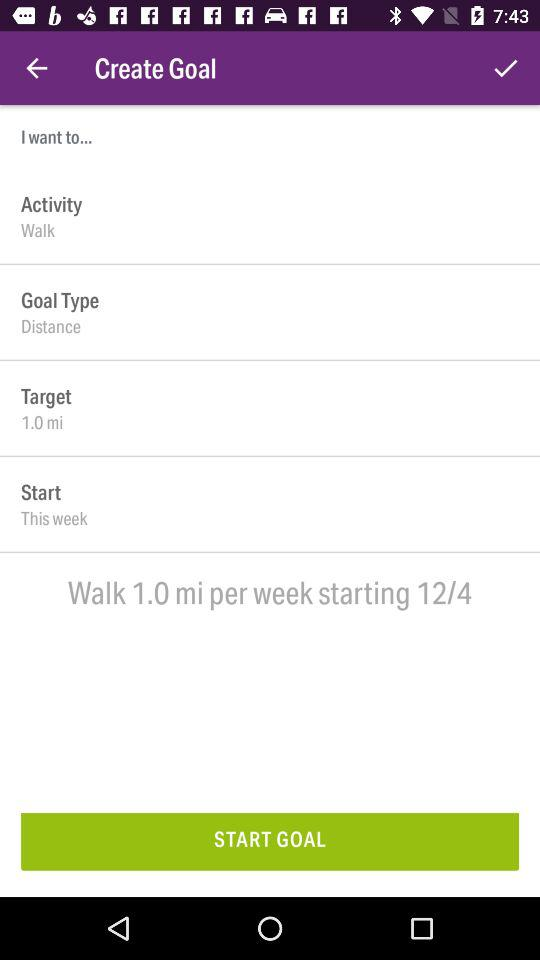How much distance is the goal?
Answer the question using a single word or phrase. 1.0 mi 